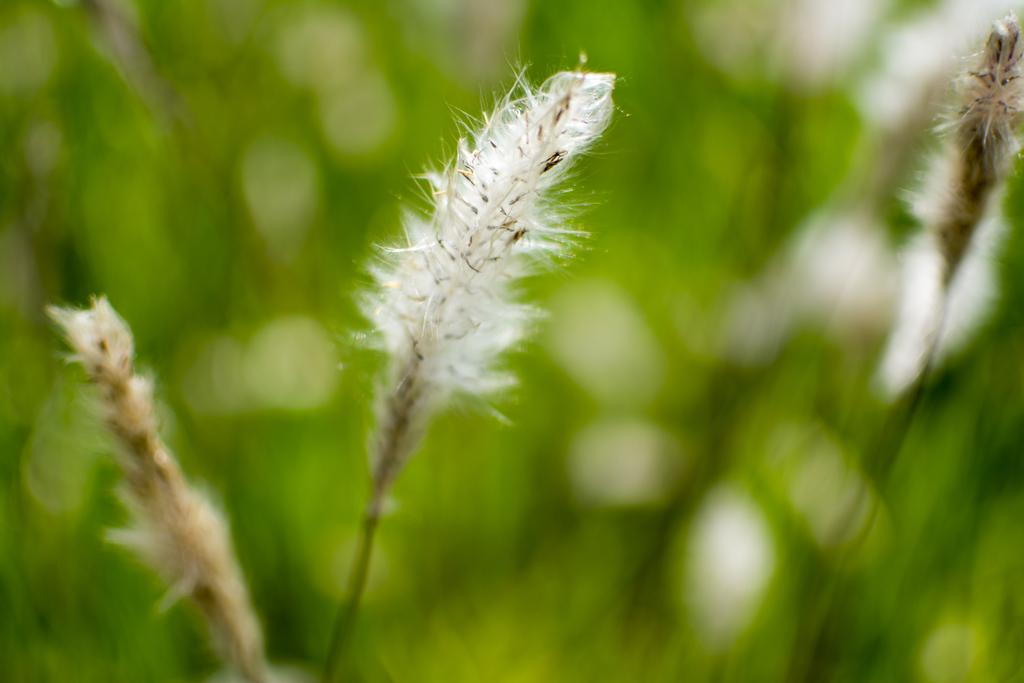What is present in the image? There are flowers in the image. Can you describe the background of the image? The background of the image is blurred. What type of horn can be heard in the image? There is no horn or sound present in the image, as it is a still image featuring flowers. 